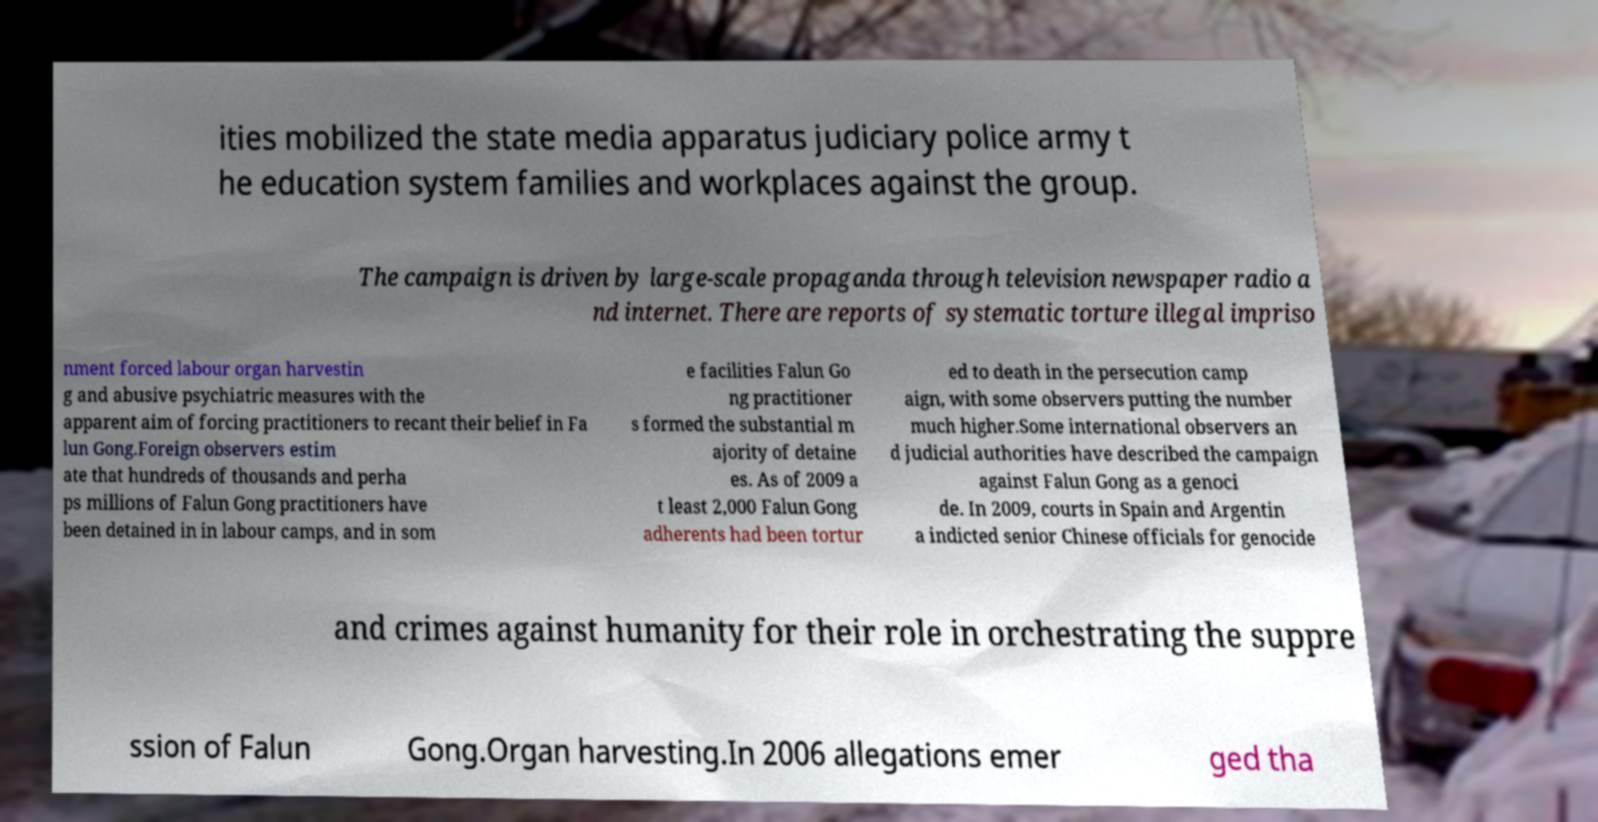Could you extract and type out the text from this image? ities mobilized the state media apparatus judiciary police army t he education system families and workplaces against the group. The campaign is driven by large-scale propaganda through television newspaper radio a nd internet. There are reports of systematic torture illegal impriso nment forced labour organ harvestin g and abusive psychiatric measures with the apparent aim of forcing practitioners to recant their belief in Fa lun Gong.Foreign observers estim ate that hundreds of thousands and perha ps millions of Falun Gong practitioners have been detained in in labour camps, and in som e facilities Falun Go ng practitioner s formed the substantial m ajority of detaine es. As of 2009 a t least 2,000 Falun Gong adherents had been tortur ed to death in the persecution camp aign, with some observers putting the number much higher.Some international observers an d judicial authorities have described the campaign against Falun Gong as a genoci de. In 2009, courts in Spain and Argentin a indicted senior Chinese officials for genocide and crimes against humanity for their role in orchestrating the suppre ssion of Falun Gong.Organ harvesting.In 2006 allegations emer ged tha 